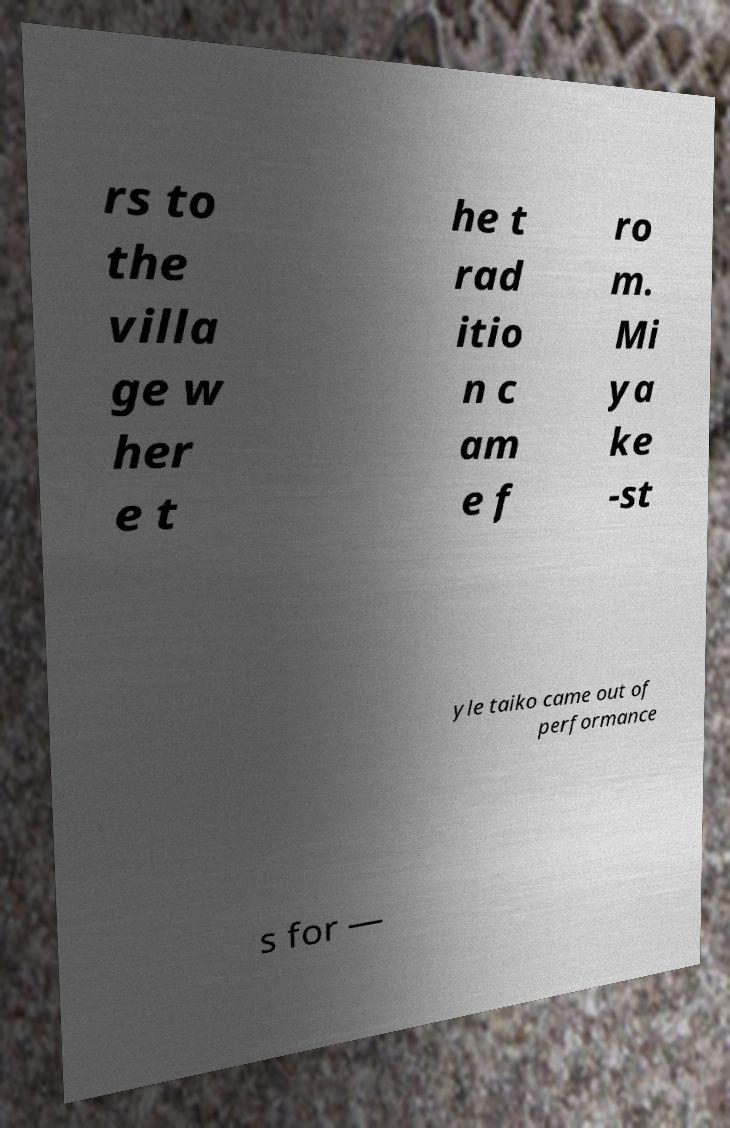I need the written content from this picture converted into text. Can you do that? rs to the villa ge w her e t he t rad itio n c am e f ro m. Mi ya ke -st yle taiko came out of performance s for — 